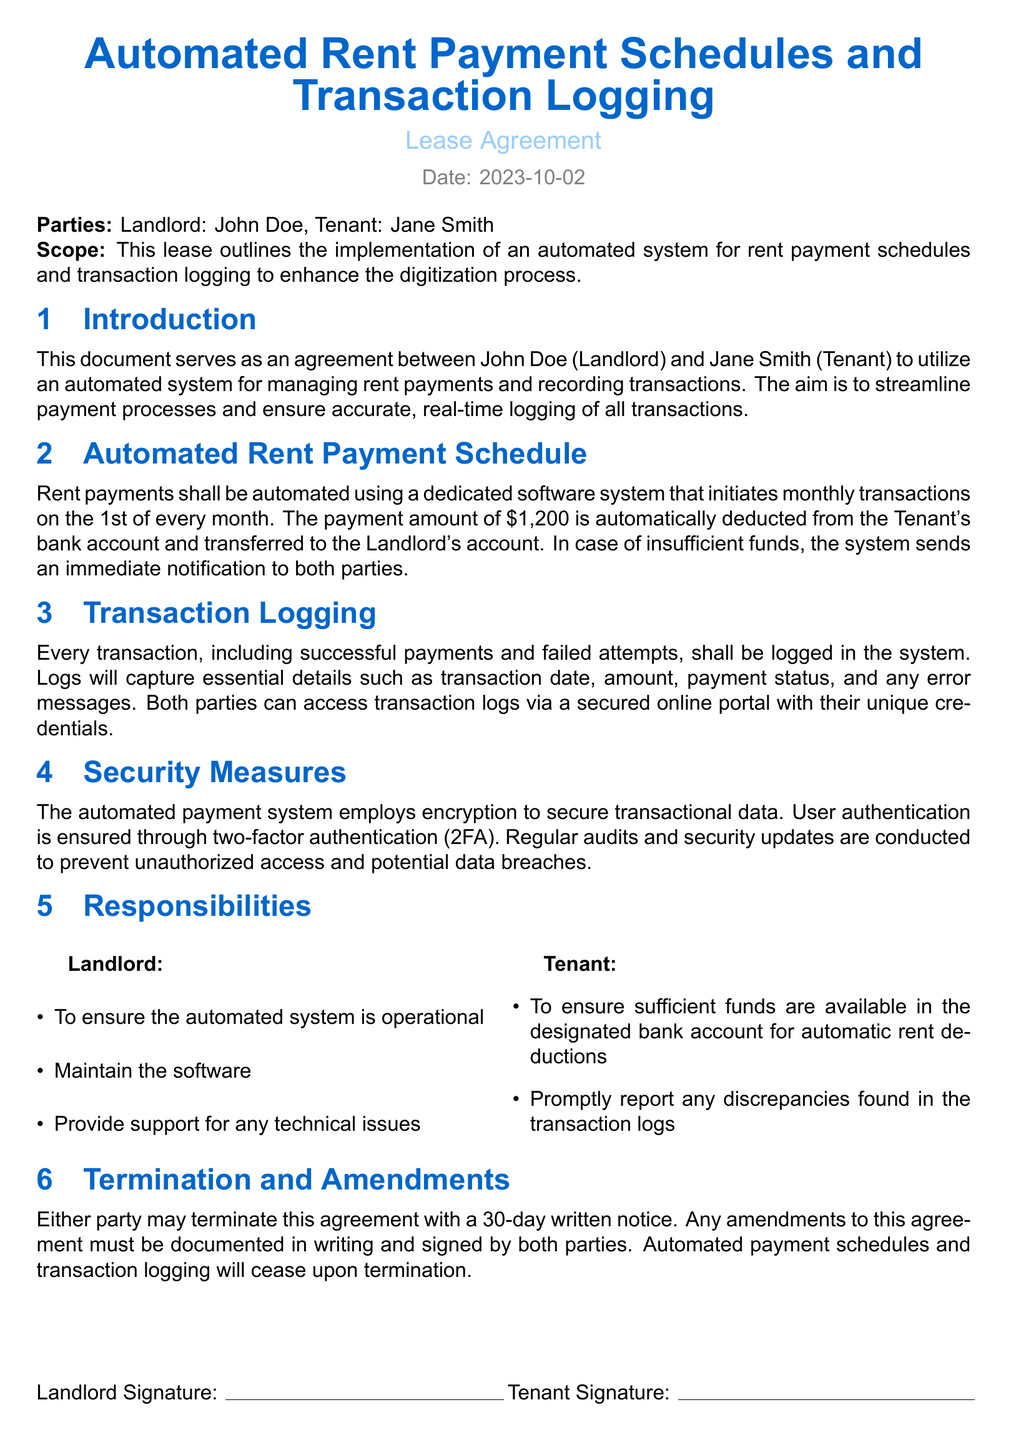What is the date of the lease agreement? The date is explicitly stated at the top of the document as the day the lease is created.
Answer: 2023-10-02 Who is the Tenant in this lease agreement? The document identifies the Tenant clearly in the parties section.
Answer: Jane Smith What is the automated payment amount? The agreement specifies the monthly deduction amount for rent.
Answer: $1,200 What is the payment initiation date every month? The document details when the automated payments are scheduled to occur each month.
Answer: 1st What are the security measures mentioned? The document outlines specific security practices associated with the automated payment system.
Answer: Encryption and 2FA What must the Tenant do regarding their bank account? The responsibilities section outlines the Tenant's obligation concerning finances.
Answer: Ensure sufficient funds How long is the written notice for termination? The agreement defines the period for notice before termination can occur.
Answer: 30 days What should happen if there are insufficient funds? The document outlines the protocol in case the Tenant's account does not have enough funds.
Answer: Immediate notification What should be documented for any amendments to the agreement? The termination and amendments section specifies how any changes should be handled.
Answer: In writing and signed by both parties 